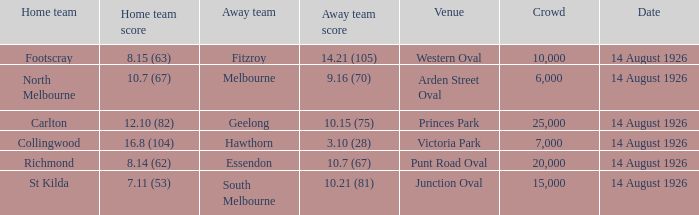What was the crowd size at Victoria Park? 7000.0. 